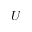<formula> <loc_0><loc_0><loc_500><loc_500>U</formula> 